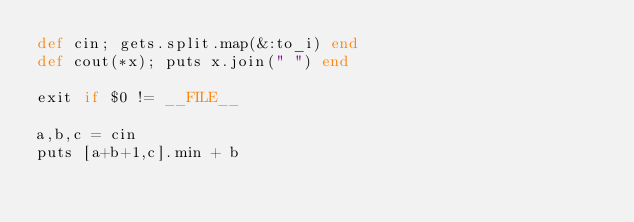Convert code to text. <code><loc_0><loc_0><loc_500><loc_500><_Ruby_>def cin; gets.split.map(&:to_i) end
def cout(*x); puts x.join(" ") end

exit if $0 != __FILE__

a,b,c = cin
puts [a+b+1,c].min + b
</code> 